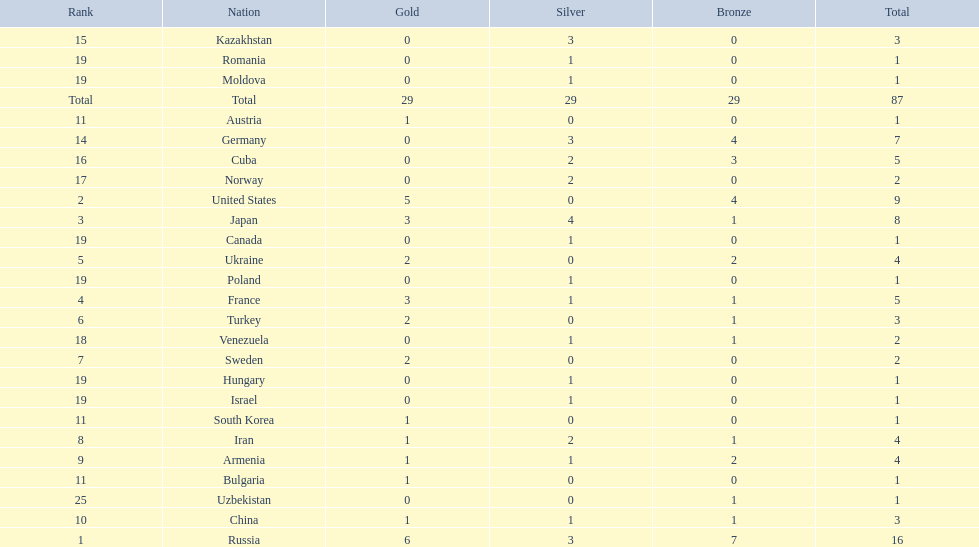Which nations participated in the championships? Russia, United States, Japan, France, Ukraine, Turkey, Sweden, Iran, Armenia, China, Austria, Bulgaria, South Korea, Germany, Kazakhstan, Cuba, Norway, Venezuela, Canada, Hungary, Israel, Moldova, Poland, Romania, Uzbekistan. How many bronze medals did they receive? 7, 4, 1, 1, 2, 1, 0, 1, 2, 1, 0, 0, 0, 4, 0, 3, 0, 1, 0, 0, 0, 0, 0, 0, 1, 29. How many in total? 16, 9, 8, 5, 4, 3, 2, 4, 4, 3, 1, 1, 1, 7, 3, 5, 2, 2, 1, 1, 1, 1, 1, 1, 1. And which team won only one medal -- the bronze? Uzbekistan. 